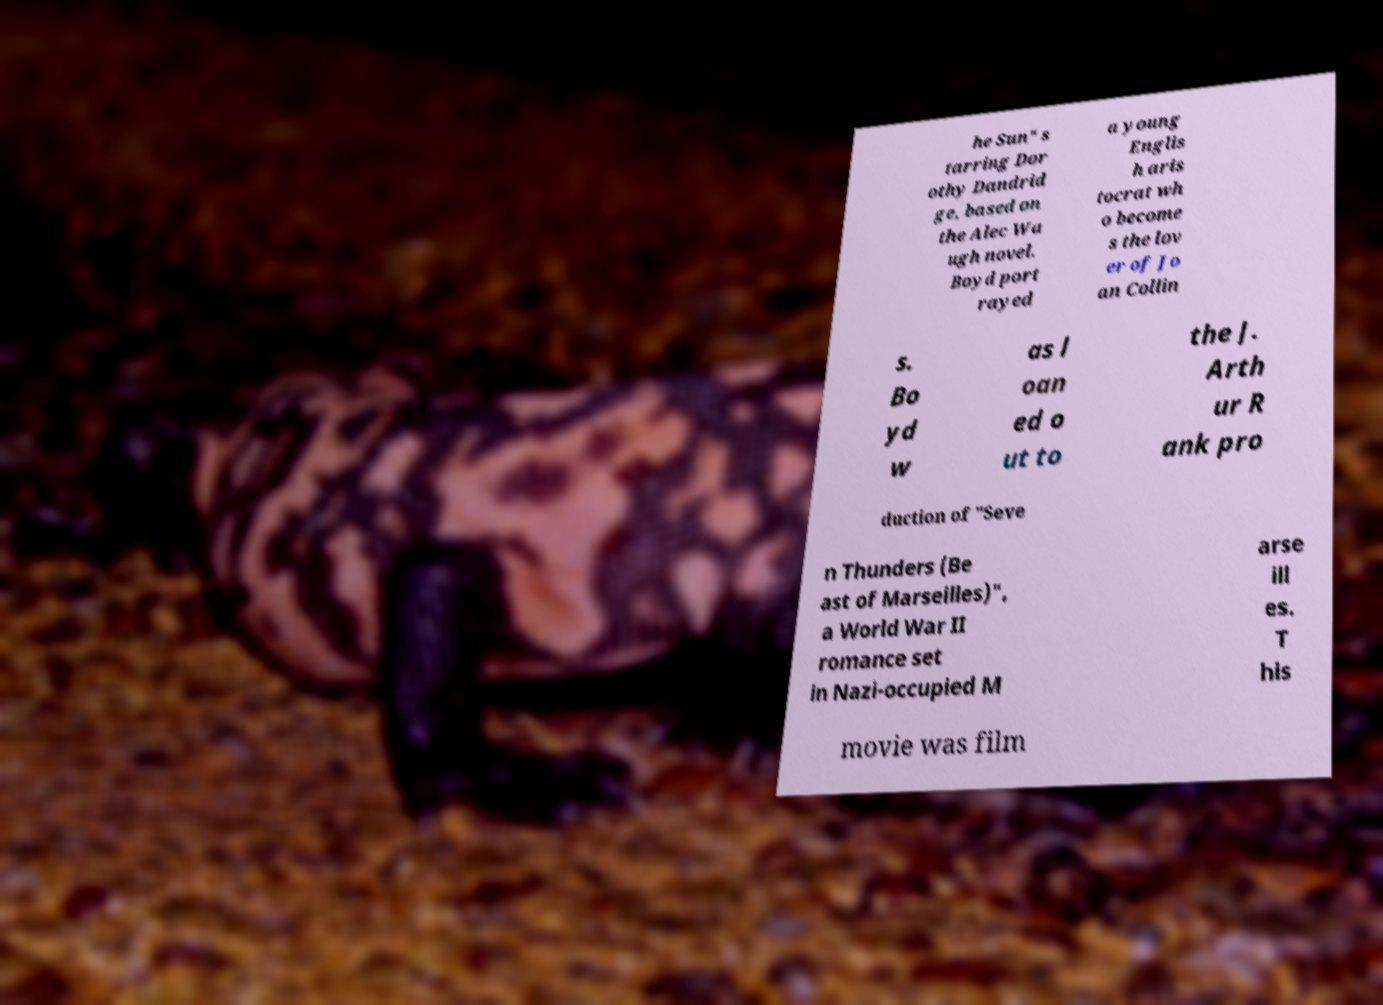I need the written content from this picture converted into text. Can you do that? he Sun" s tarring Dor othy Dandrid ge, based on the Alec Wa ugh novel. Boyd port rayed a young Englis h aris tocrat wh o become s the lov er of Jo an Collin s. Bo yd w as l oan ed o ut to the J. Arth ur R ank pro duction of "Seve n Thunders (Be ast of Marseilles)", a World War II romance set in Nazi-occupied M arse ill es. T his movie was film 